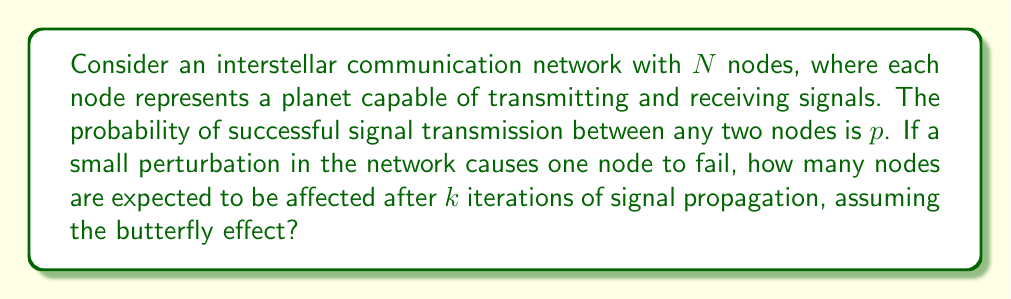Provide a solution to this math problem. 1. Let's define $E_k$ as the expected number of affected nodes after $k$ iterations.

2. Initially, one node fails, so $E_0 = 1$.

3. In each iteration, the affected nodes can potentially impact the remaining nodes:
   $$E_{k+1} = E_k + (N - E_k) \cdot (1 - (1-p)^{E_k})$$

4. This equation represents:
   - $E_k$: nodes already affected
   - $(N - E_k)$: remaining unaffected nodes
   - $(1 - (1-p)^{E_k})$: probability of at least one affected node successfully transmitting to an unaffected node

5. To solve this, we need to iterate $k$ times:

   For $k = 1$:
   $$E_1 = 1 + (N - 1) \cdot (1 - (1-p)^1)$$

   For $k = 2$:
   $$E_2 = E_1 + (N - E_1) \cdot (1 - (1-p)^{E_1})$$

   And so on, until we reach the $k$th iteration.

6. The final value of $E_k$ represents the expected number of affected nodes after $k$ iterations.

7. Note: This model assumes independent probabilities and doesn't account for network topology or signal decay over long distances.
Answer: $$E_k = E_{k-1} + (N - E_{k-1}) \cdot (1 - (1-p)^{E_{k-1}})$$ 